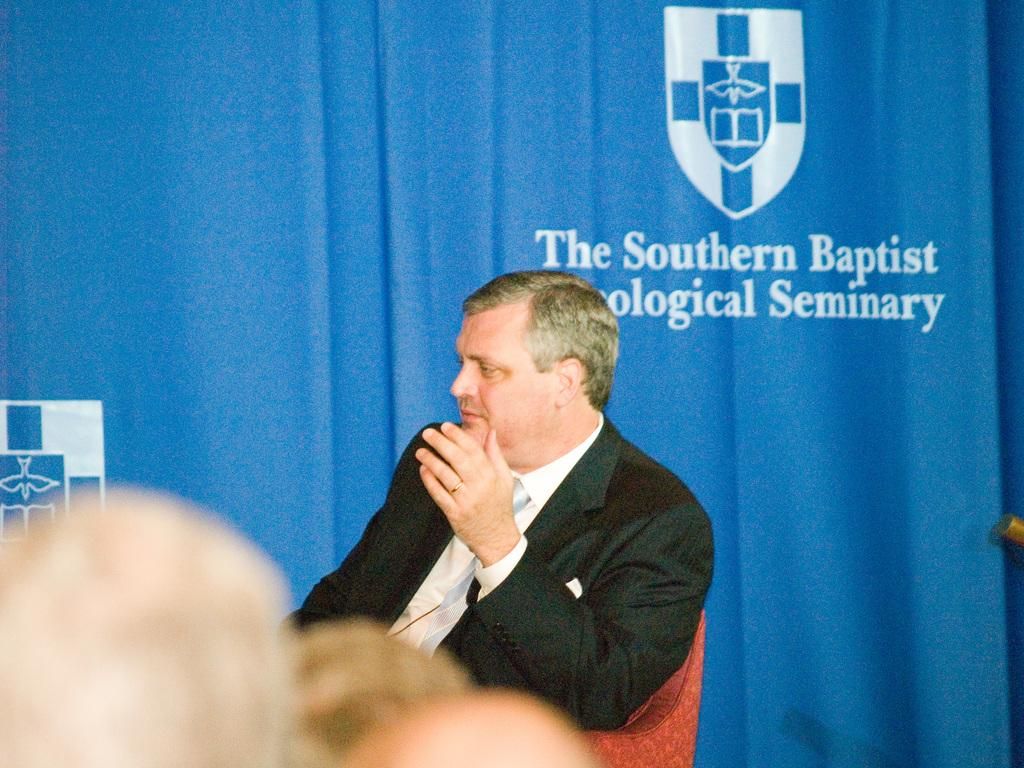What is the man in the image doing? The man is sitting on a chair in the image. What can be seen behind the man? There is a curtain with text behind the man. Are there any other people in the image? Yes, there are people present in front of the man. 